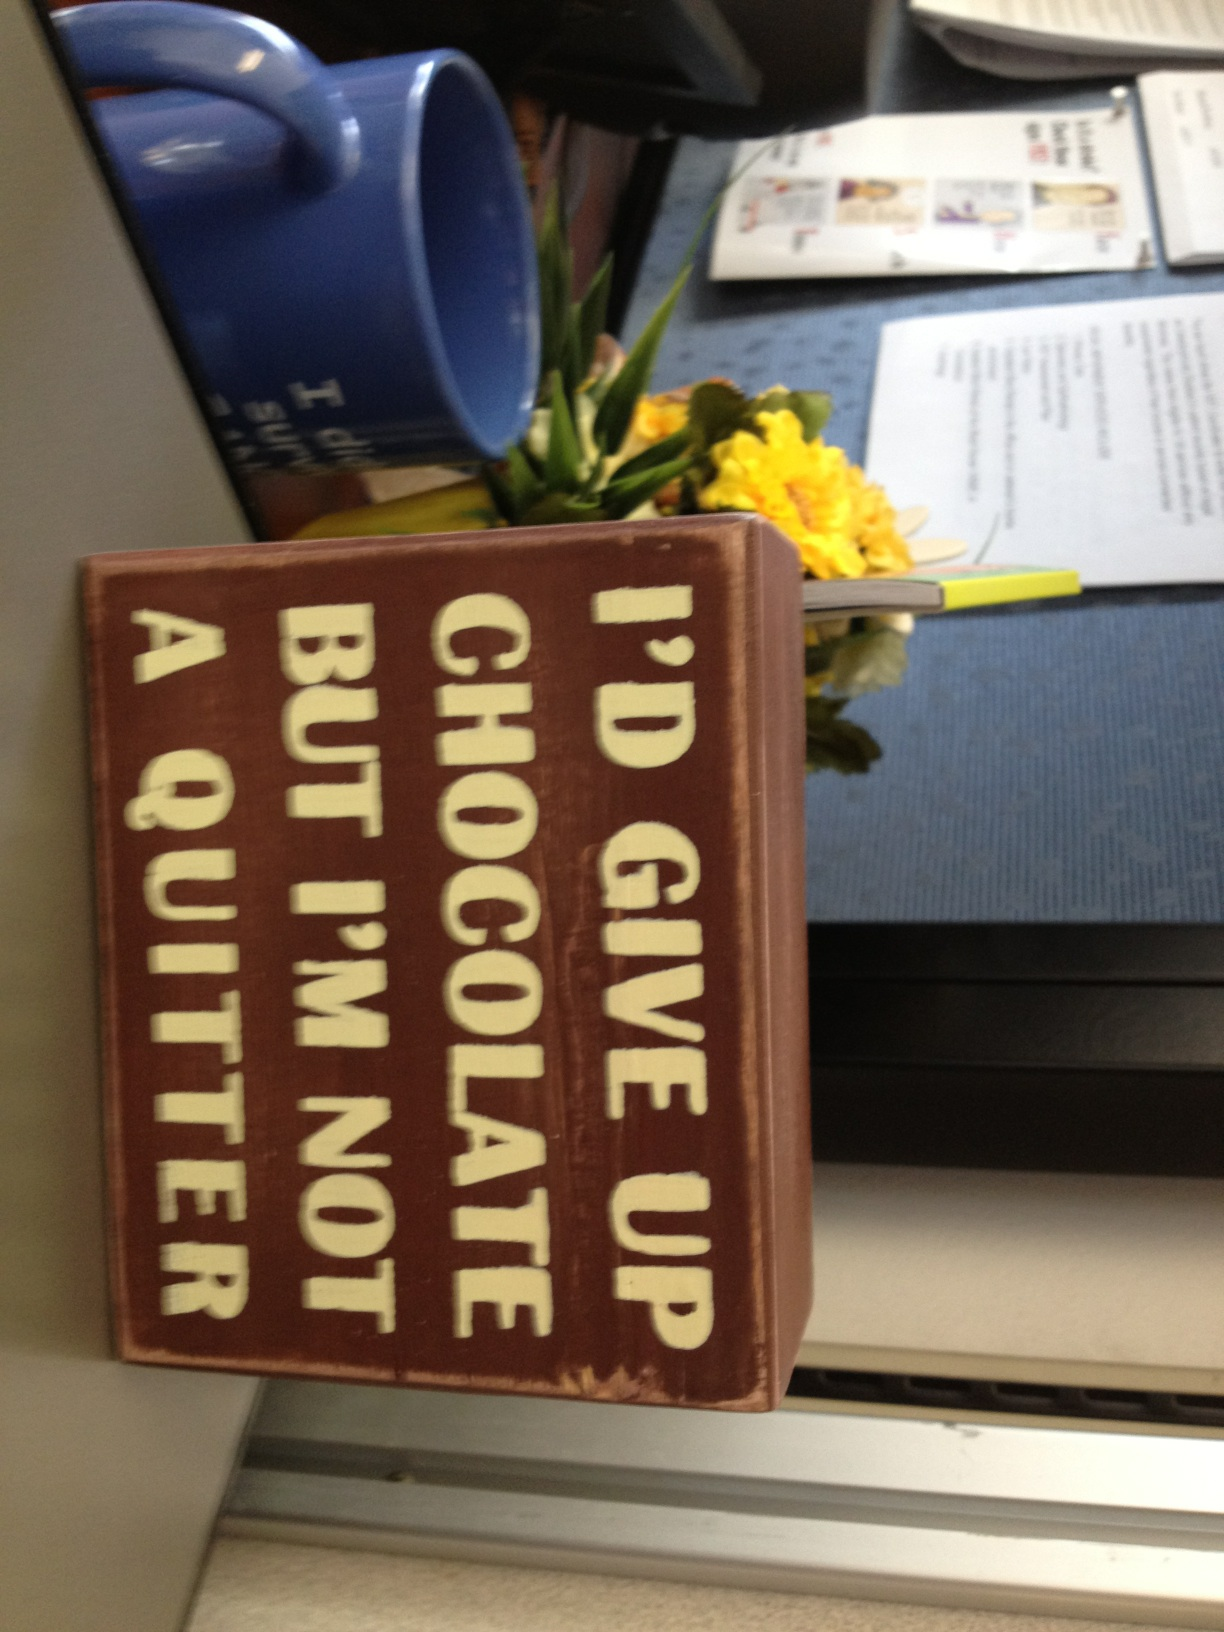If this sign had a sequel, what would it say? If this sign had a sequel, it might say, 'Life is short, eat dessert first.' This would continue the theme of light-hearted humor and enjoyment of life's simple pleasures, aligning with the original message's playful tone. How could the workspace be arranged to enhance productivity? To enhance productivity in the workspace seen in the image, several changes could be made: 
1. **Organization:** Ensure that all papers and documents are neatly organized and are easily accessible. Consider using filing systems or trays. 
2. **Lighting:** Good lighting is essential. Ensure there is enough natural or artificial light to prevent eye strain. 
3. **Declutter:** Keep the desk clear of unnecessary items. This can reduce distractions and help focus on tasks. 
4. **Personal Touch:** Adding some personal or motivational items, like the sign in the image, can make the workspace feel more inviting and motivating. 
5. **Ergonomics:** Ensure the chair and desk setup is ergonomically sound to prevent discomfort during long working hours. This might involve adjustable chairs, monitor stands, and proper keyboard placement. 